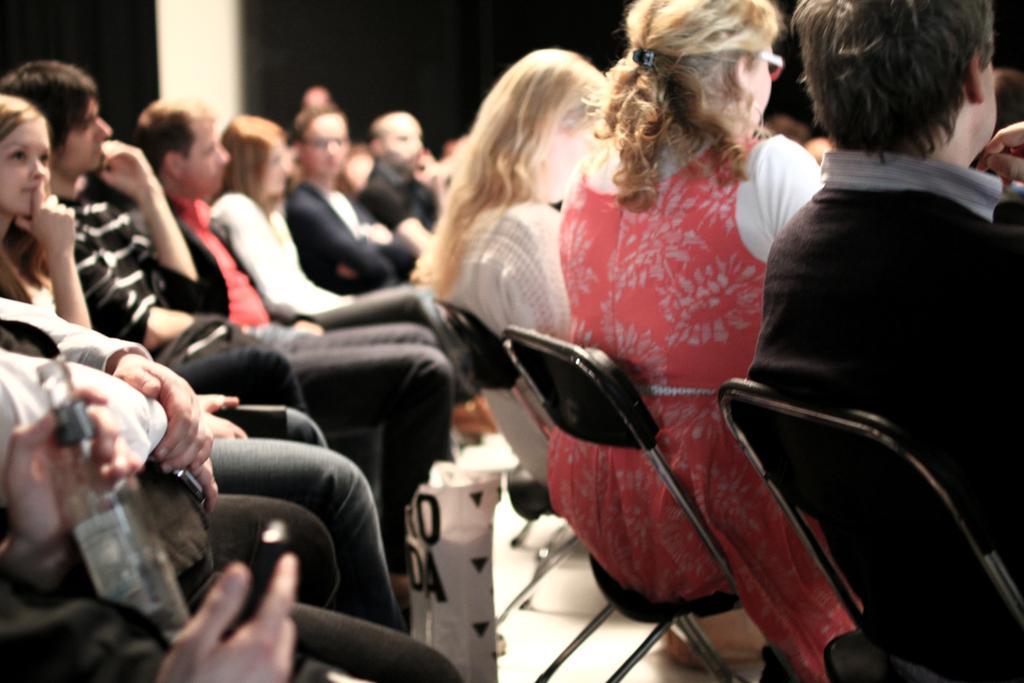Please provide a concise description of this image. In the given image i can see a people,chairs and bottle. 